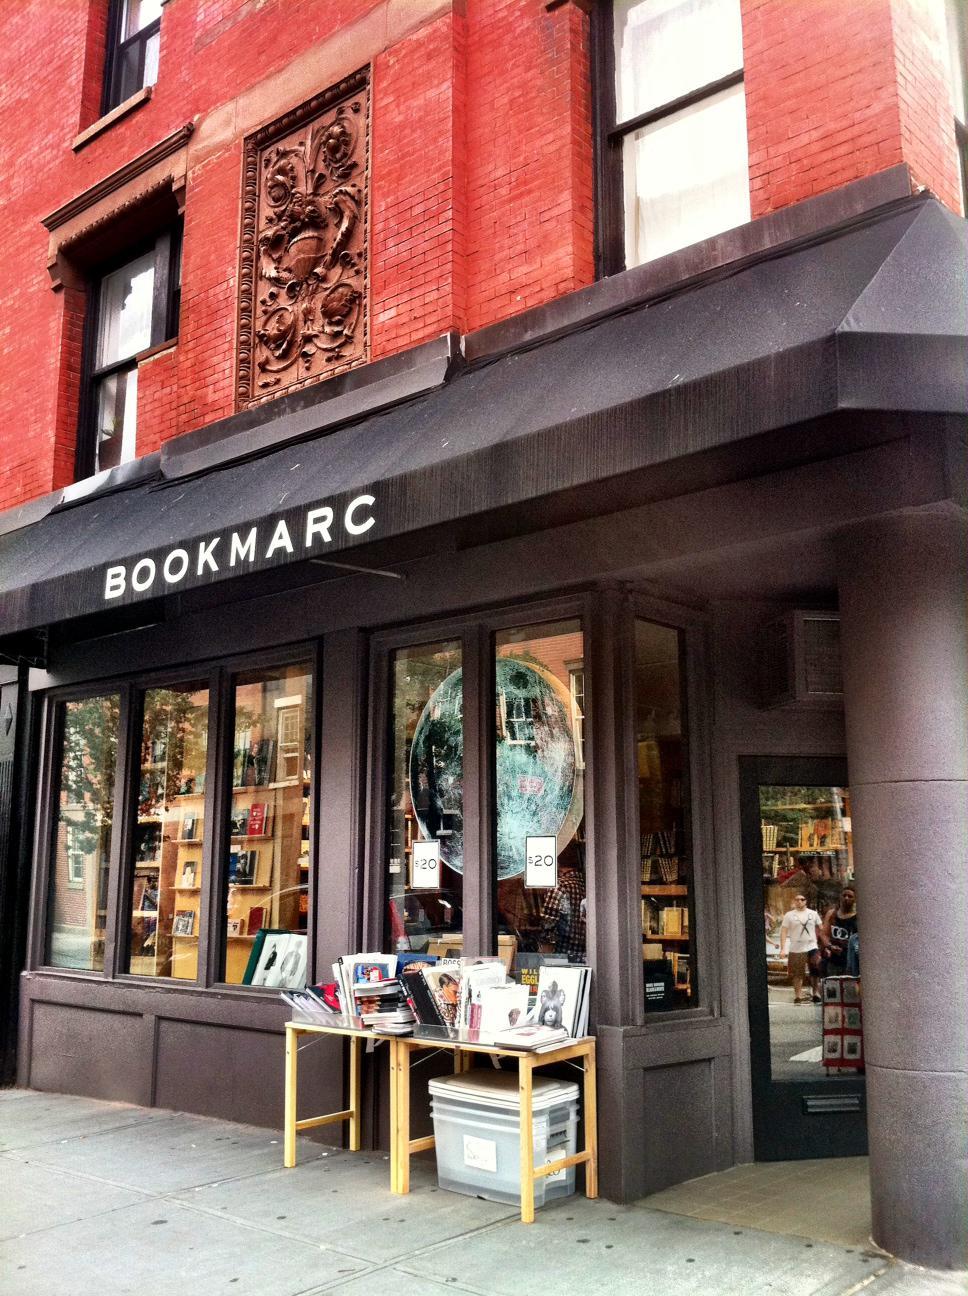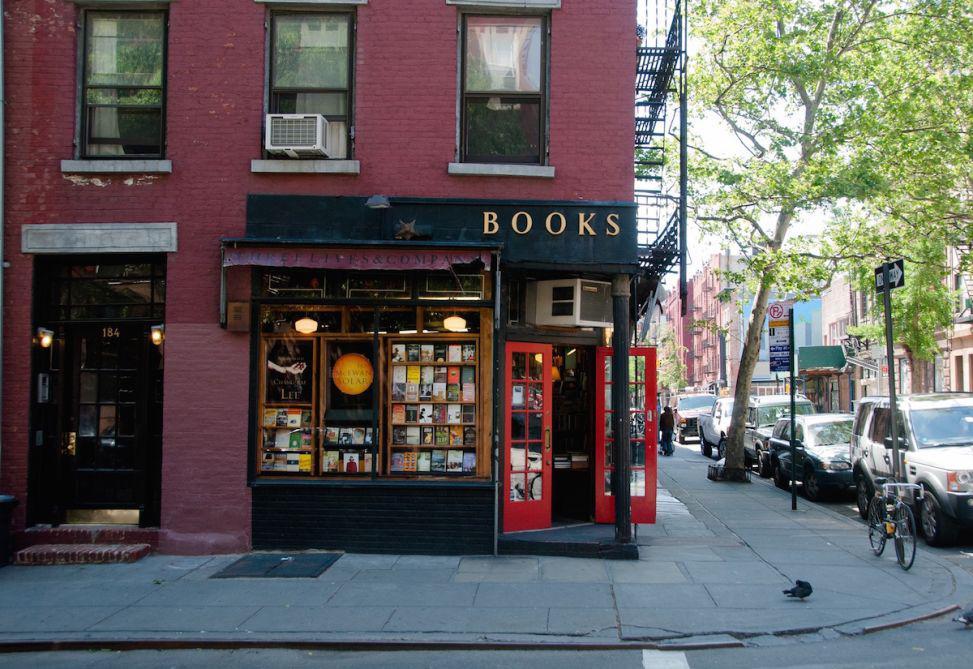The first image is the image on the left, the second image is the image on the right. Considering the images on both sides, is "The store in the right image has a red door with multiple windows built into the door." valid? Answer yes or no. Yes. The first image is the image on the left, the second image is the image on the right. Analyze the images presented: Is the assertion "In one of the image a red door is open." valid? Answer yes or no. Yes. 